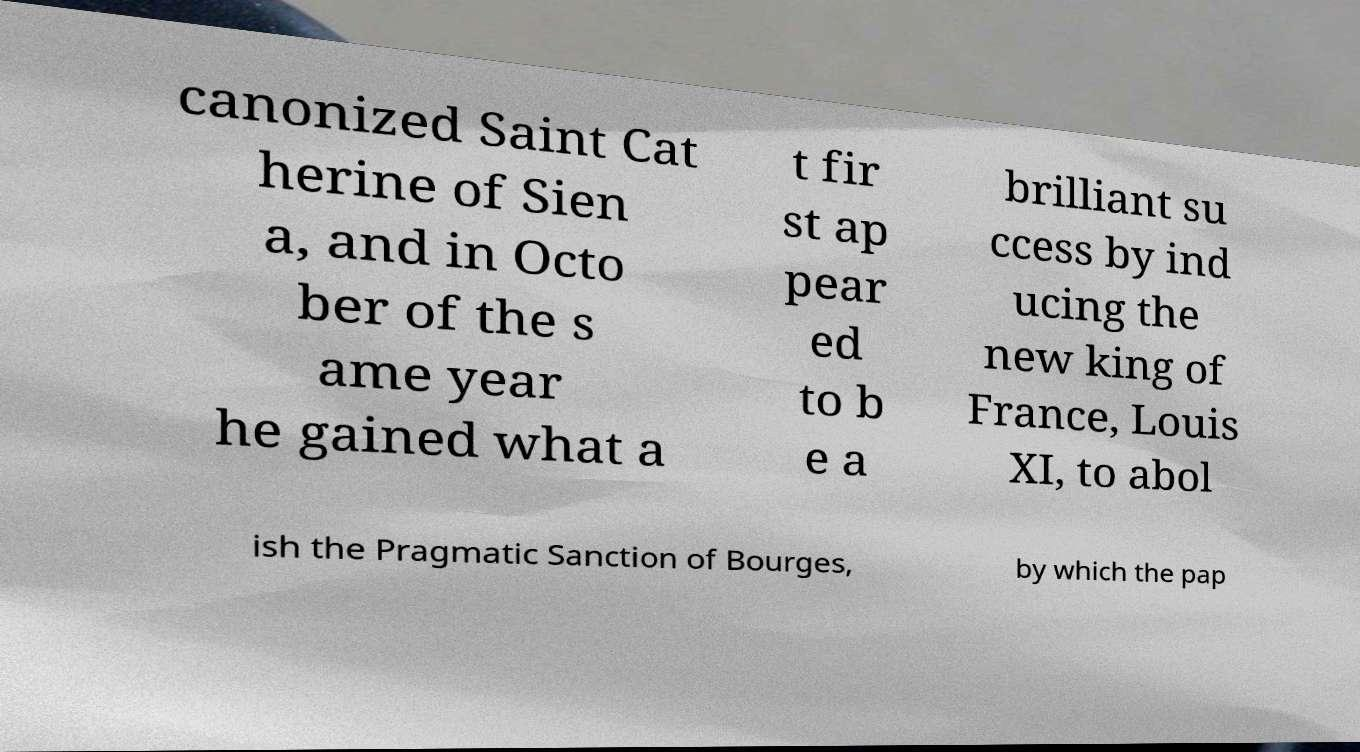Can you accurately transcribe the text from the provided image for me? canonized Saint Cat herine of Sien a, and in Octo ber of the s ame year he gained what a t fir st ap pear ed to b e a brilliant su ccess by ind ucing the new king of France, Louis XI, to abol ish the Pragmatic Sanction of Bourges, by which the pap 